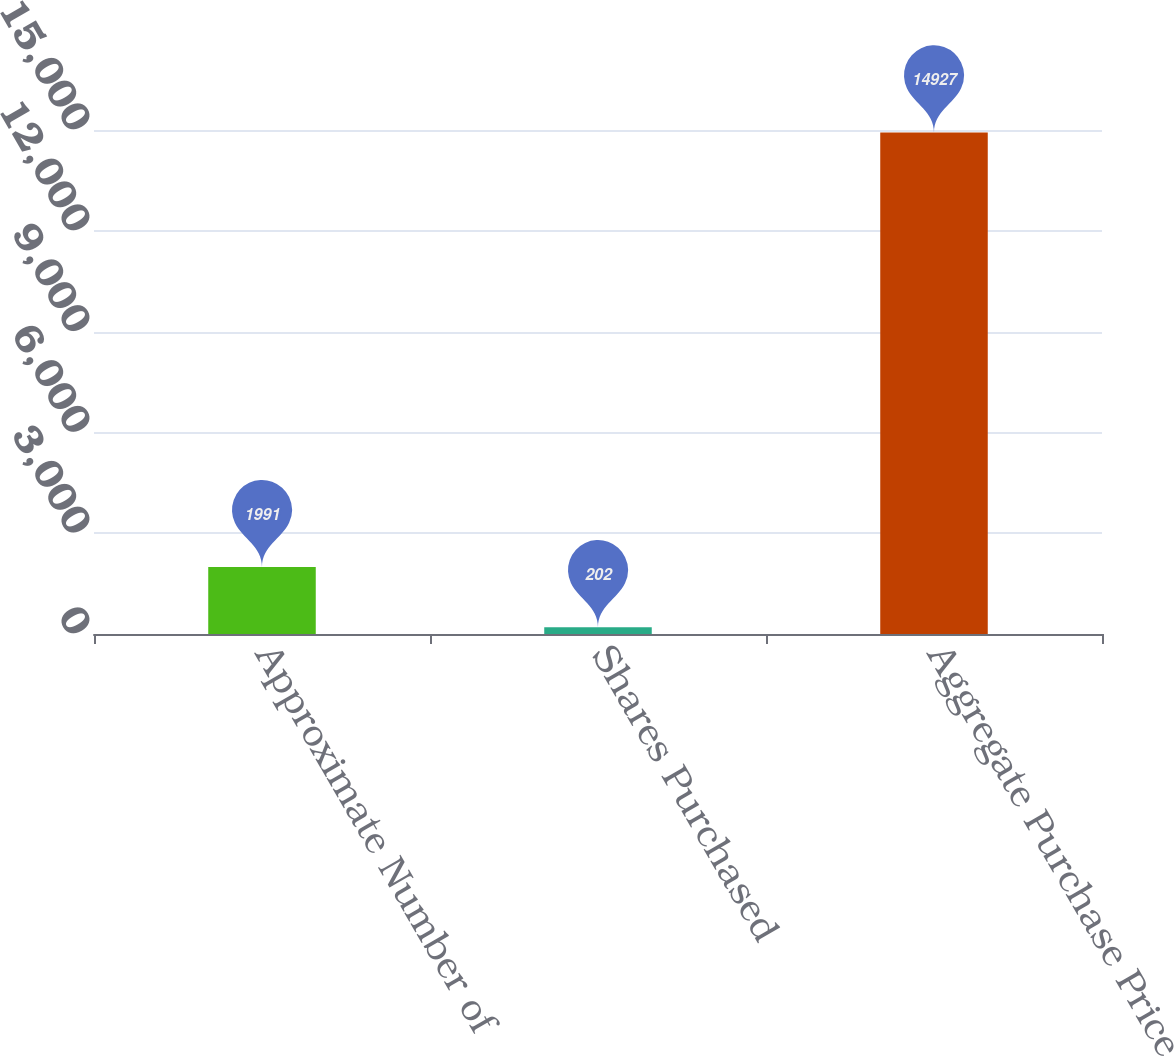Convert chart to OTSL. <chart><loc_0><loc_0><loc_500><loc_500><bar_chart><fcel>Approximate Number of<fcel>Shares Purchased<fcel>Aggregate Purchase Price<nl><fcel>1991<fcel>202<fcel>14927<nl></chart> 